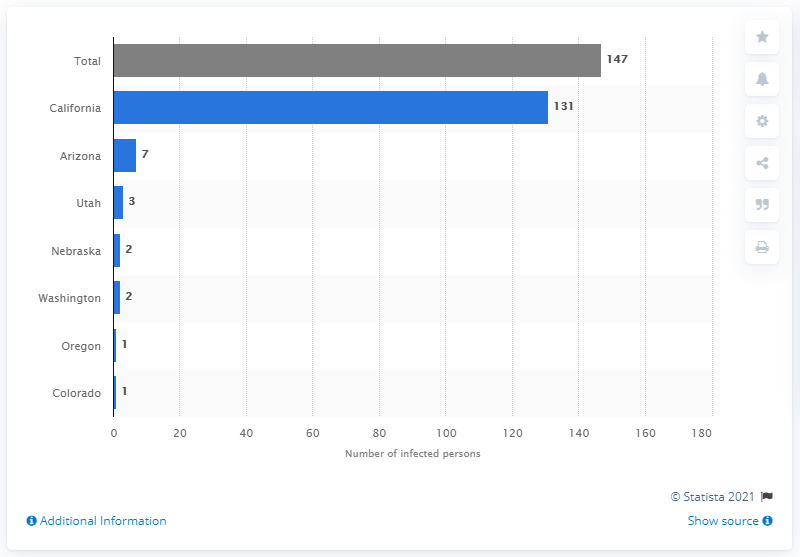Highlight a few significant elements in this photo. During the period of December 28, 2014 and April 10, 2015, a total of 147 individuals contracted measles. 